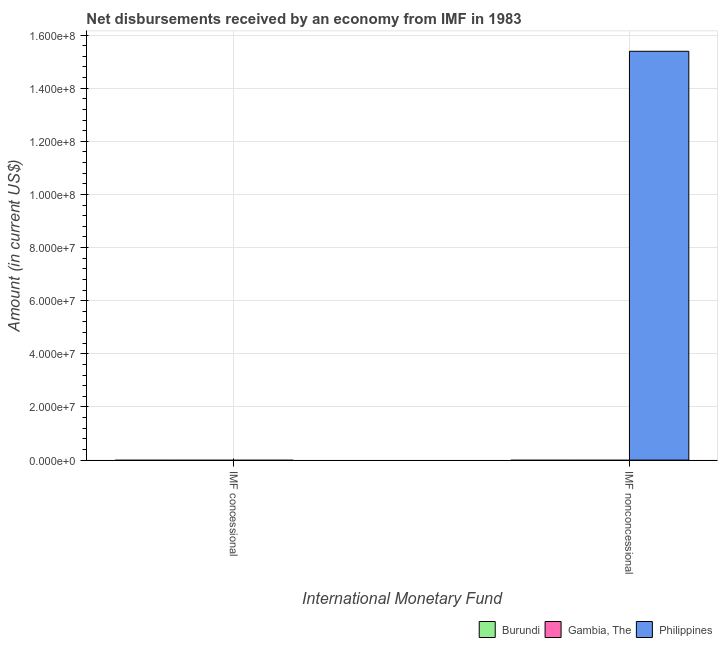Are the number of bars per tick equal to the number of legend labels?
Offer a terse response. No. How many bars are there on the 2nd tick from the right?
Make the answer very short. 0. What is the label of the 1st group of bars from the left?
Offer a very short reply. IMF concessional. What is the net non concessional disbursements from imf in Burundi?
Give a very brief answer. 0. Across all countries, what is the maximum net non concessional disbursements from imf?
Keep it short and to the point. 1.54e+08. Across all countries, what is the minimum net concessional disbursements from imf?
Keep it short and to the point. 0. In which country was the net non concessional disbursements from imf maximum?
Keep it short and to the point. Philippines. What is the total net non concessional disbursements from imf in the graph?
Keep it short and to the point. 1.54e+08. What is the difference between the net concessional disbursements from imf in Gambia, The and the net non concessional disbursements from imf in Philippines?
Give a very brief answer. -1.54e+08. What is the average net non concessional disbursements from imf per country?
Give a very brief answer. 5.13e+07. In how many countries, is the net concessional disbursements from imf greater than 32000000 US$?
Provide a short and direct response. 0. Are all the bars in the graph horizontal?
Keep it short and to the point. No. How many countries are there in the graph?
Provide a succinct answer. 3. What is the difference between two consecutive major ticks on the Y-axis?
Make the answer very short. 2.00e+07. Are the values on the major ticks of Y-axis written in scientific E-notation?
Offer a terse response. Yes. Does the graph contain any zero values?
Your answer should be very brief. Yes. Does the graph contain grids?
Provide a succinct answer. Yes. Where does the legend appear in the graph?
Give a very brief answer. Bottom right. How are the legend labels stacked?
Keep it short and to the point. Horizontal. What is the title of the graph?
Provide a short and direct response. Net disbursements received by an economy from IMF in 1983. What is the label or title of the X-axis?
Your response must be concise. International Monetary Fund. What is the Amount (in current US$) of Gambia, The in IMF concessional?
Your response must be concise. 0. What is the Amount (in current US$) in Philippines in IMF concessional?
Your answer should be very brief. 0. What is the Amount (in current US$) in Gambia, The in IMF nonconcessional?
Ensure brevity in your answer.  0. What is the Amount (in current US$) of Philippines in IMF nonconcessional?
Keep it short and to the point. 1.54e+08. Across all International Monetary Fund, what is the maximum Amount (in current US$) in Philippines?
Give a very brief answer. 1.54e+08. Across all International Monetary Fund, what is the minimum Amount (in current US$) of Philippines?
Provide a short and direct response. 0. What is the total Amount (in current US$) in Burundi in the graph?
Provide a succinct answer. 0. What is the total Amount (in current US$) of Philippines in the graph?
Offer a terse response. 1.54e+08. What is the average Amount (in current US$) in Burundi per International Monetary Fund?
Your response must be concise. 0. What is the average Amount (in current US$) of Philippines per International Monetary Fund?
Your response must be concise. 7.70e+07. What is the difference between the highest and the lowest Amount (in current US$) of Philippines?
Keep it short and to the point. 1.54e+08. 